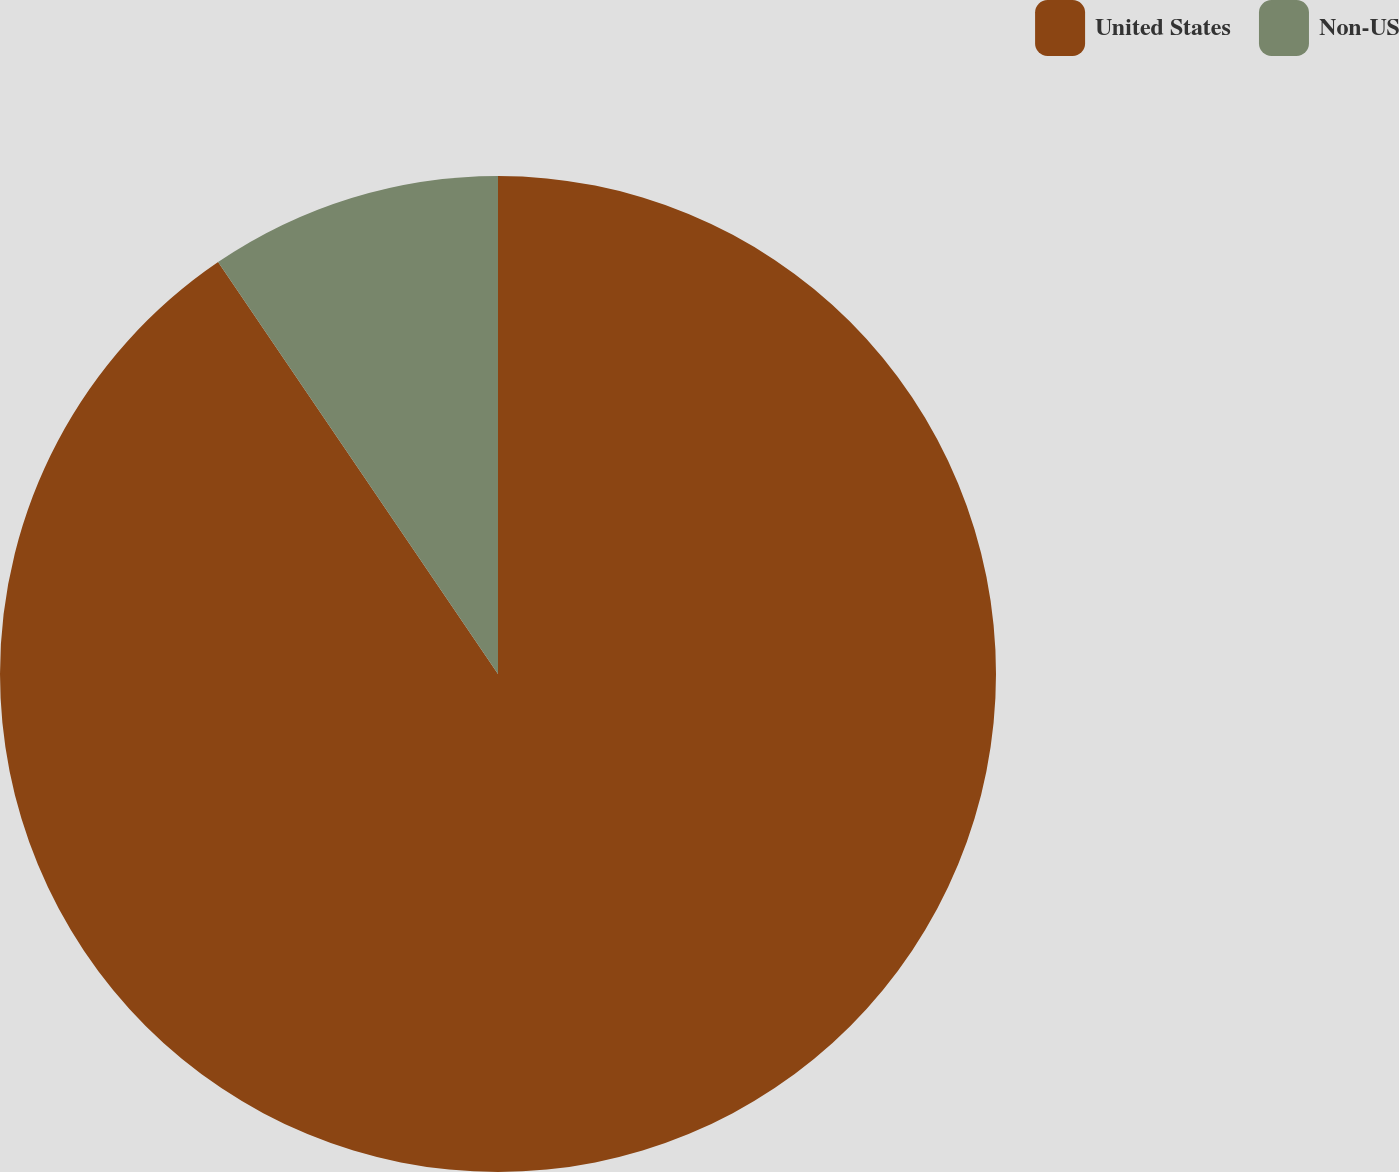Convert chart. <chart><loc_0><loc_0><loc_500><loc_500><pie_chart><fcel>United States<fcel>Non-US<nl><fcel>90.5%<fcel>9.5%<nl></chart> 